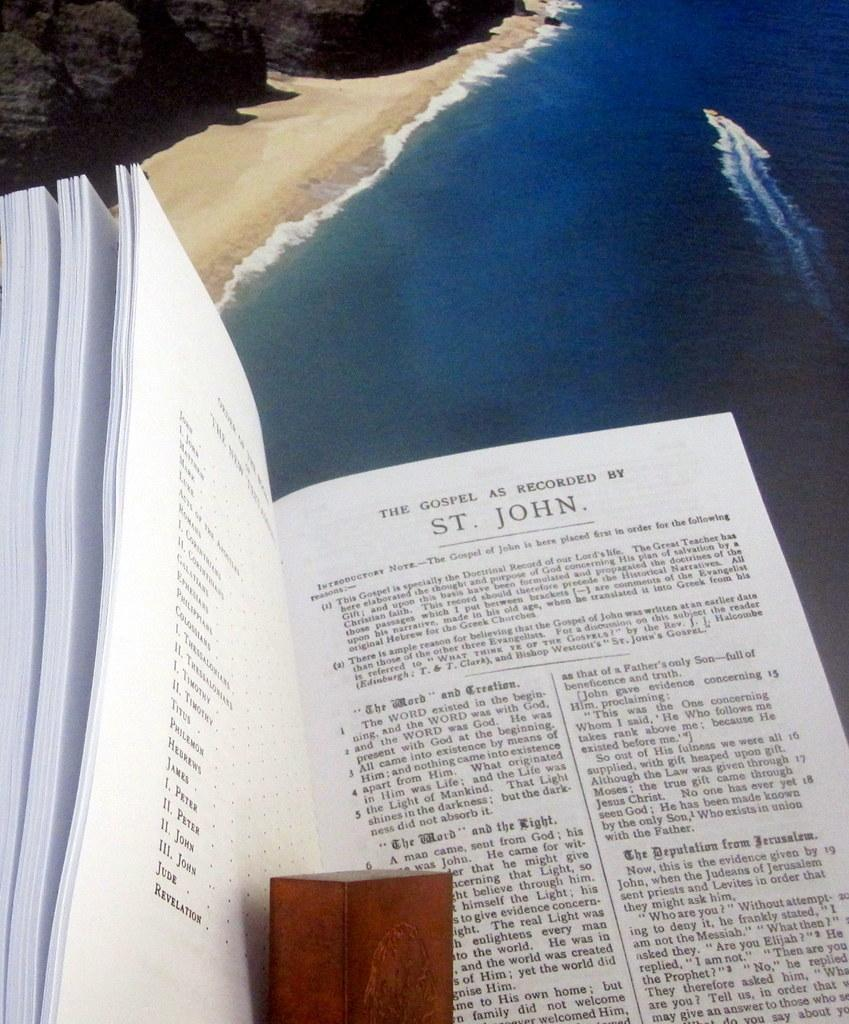<image>
Offer a succinct explanation of the picture presented. A booked titled The gospel as Recorded by St. Joseph is sitting above a blue ocean 